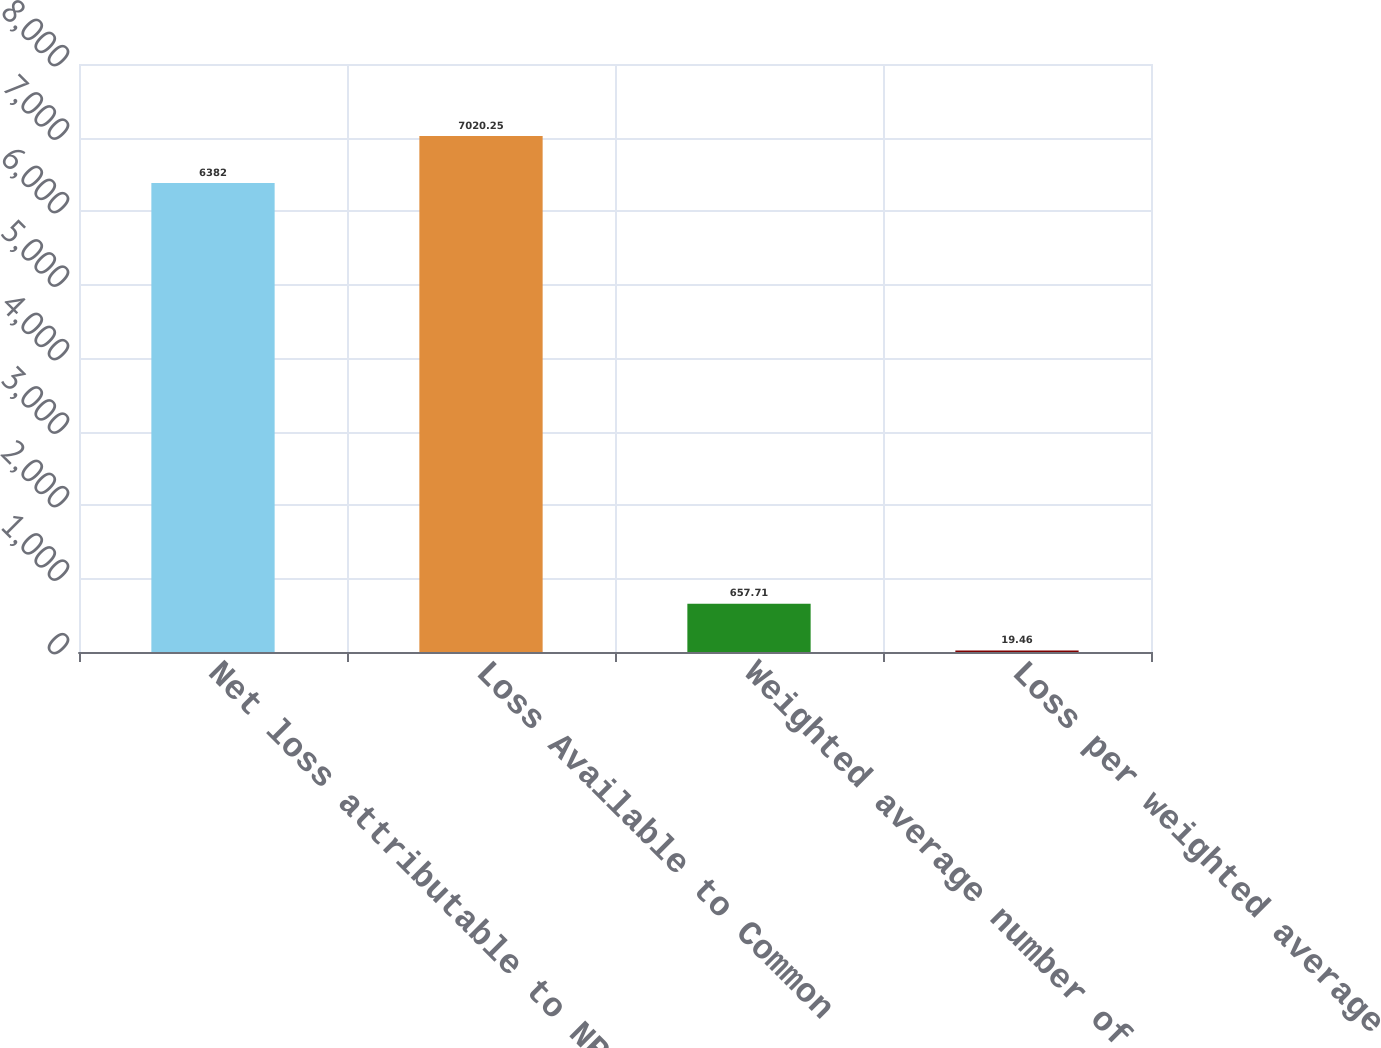<chart> <loc_0><loc_0><loc_500><loc_500><bar_chart><fcel>Net loss attributable to NRG<fcel>Loss Available to Common<fcel>Weighted average number of<fcel>Loss per weighted average<nl><fcel>6382<fcel>7020.25<fcel>657.71<fcel>19.46<nl></chart> 